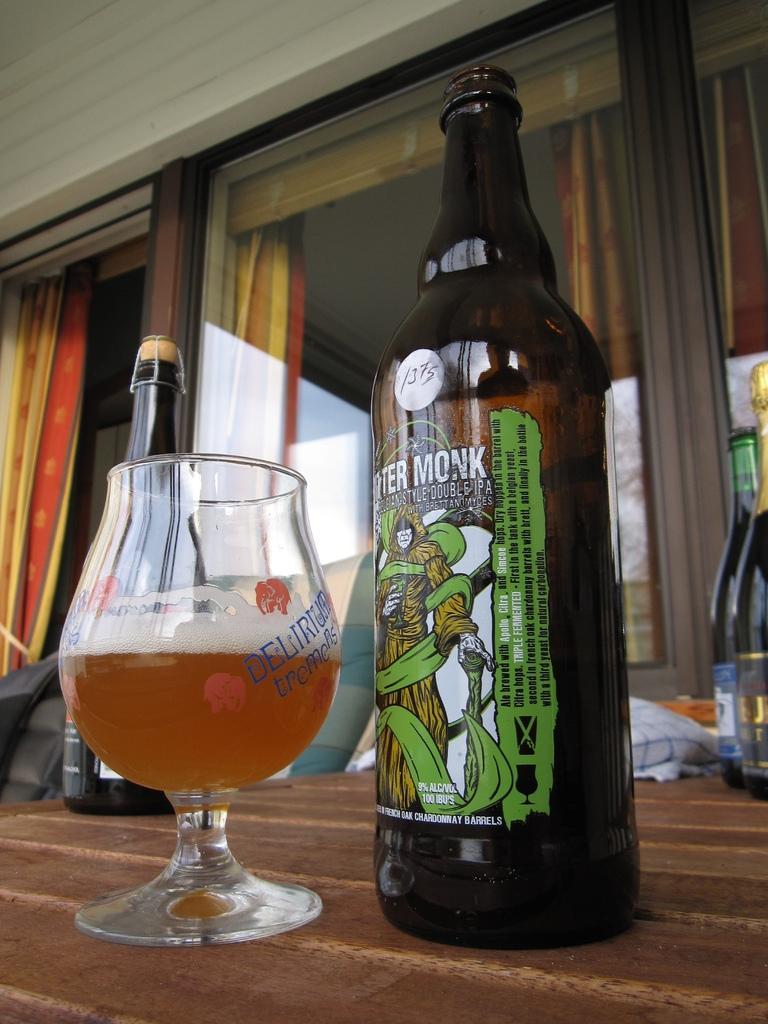Can you describe this image briefly? In this image can see the alcohol bottles and a glass of alcohol placed on the table. In the background we can see the windows with the curtains. We can also see the wall. Image also consists of some other objects. 